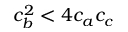Convert formula to latex. <formula><loc_0><loc_0><loc_500><loc_500>c _ { b } ^ { 2 } < 4 c _ { a } c _ { c }</formula> 